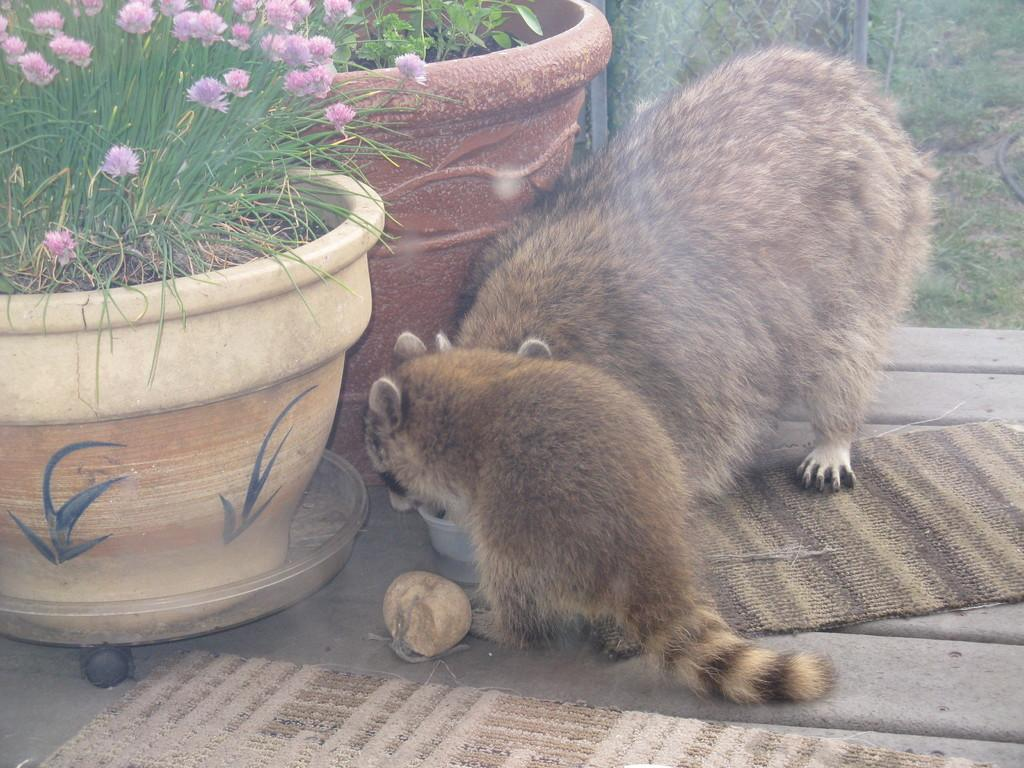What is located on the left side of the image in the front? There are animals in the front of the image on the left side. What type of vegetation is present in the image? There are plants in the image. What objects can be seen in the image? There are pots in the image. What type of ground cover is visible in the background of the image? There is grass on the ground in the background of the image. Where is the kitty studying in the image? There is no kitty or educational setting present in the image. What room is the kitty in while studying in the image? There is no kitty or room present in the image. 